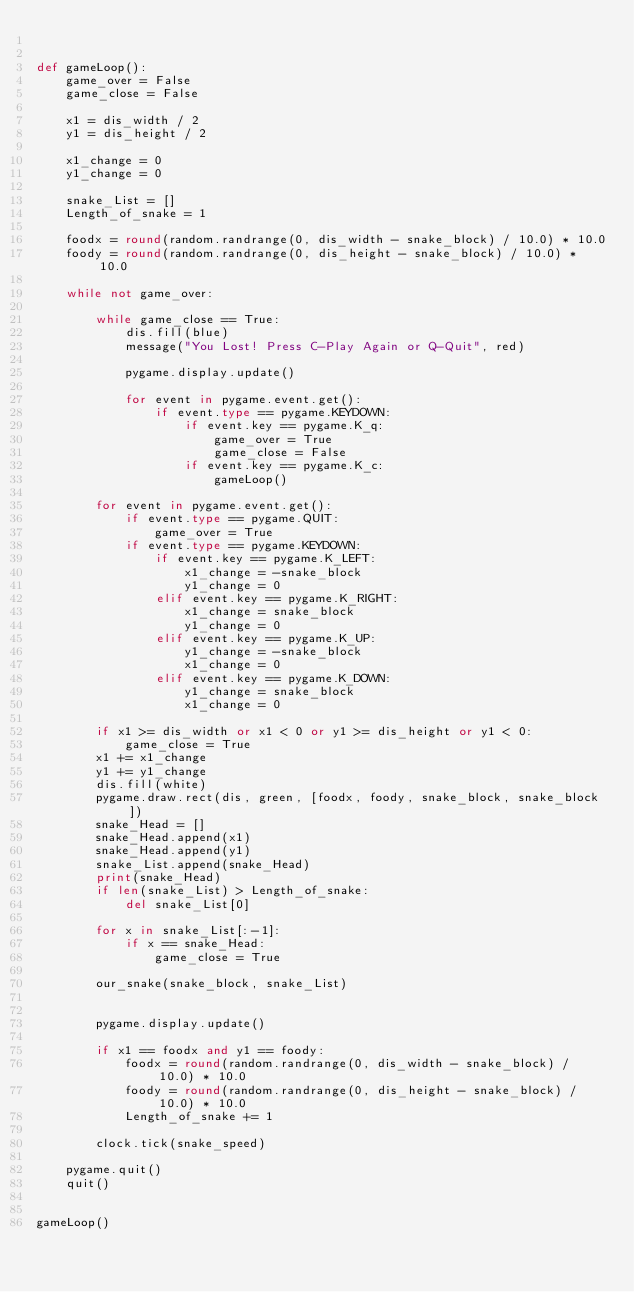<code> <loc_0><loc_0><loc_500><loc_500><_Python_> 
 
def gameLoop():
    game_over = False
    game_close = False
 
    x1 = dis_width / 2
    y1 = dis_height / 2
 
    x1_change = 0
    y1_change = 0
 
    snake_List = []
    Length_of_snake = 1
 
    foodx = round(random.randrange(0, dis_width - snake_block) / 10.0) * 10.0
    foody = round(random.randrange(0, dis_height - snake_block) / 10.0) * 10.0
 
    while not game_over:
 
        while game_close == True:
            dis.fill(blue)
            message("You Lost! Press C-Play Again or Q-Quit", red)
 
            pygame.display.update()
 
            for event in pygame.event.get():
                if event.type == pygame.KEYDOWN:
                    if event.key == pygame.K_q:
                        game_over = True
                        game_close = False
                    if event.key == pygame.K_c:
                        gameLoop()
 
        for event in pygame.event.get():
            if event.type == pygame.QUIT:
                game_over = True
            if event.type == pygame.KEYDOWN:
                if event.key == pygame.K_LEFT:
                    x1_change = -snake_block
                    y1_change = 0
                elif event.key == pygame.K_RIGHT:
                    x1_change = snake_block
                    y1_change = 0
                elif event.key == pygame.K_UP:
                    y1_change = -snake_block
                    x1_change = 0
                elif event.key == pygame.K_DOWN:
                    y1_change = snake_block
                    x1_change = 0
 
        if x1 >= dis_width or x1 < 0 or y1 >= dis_height or y1 < 0:
            game_close = True
        x1 += x1_change
        y1 += y1_change
        dis.fill(white)
        pygame.draw.rect(dis, green, [foodx, foody, snake_block, snake_block])
        snake_Head = []
        snake_Head.append(x1)
        snake_Head.append(y1)
        snake_List.append(snake_Head)
        print(snake_Head)
        if len(snake_List) > Length_of_snake:
            del snake_List[0]
 
        for x in snake_List[:-1]:
            if x == snake_Head:
                game_close = True
 
        our_snake(snake_block, snake_List)
 
 
        pygame.display.update()
 
        if x1 == foodx and y1 == foody:
            foodx = round(random.randrange(0, dis_width - snake_block) / 10.0) * 10.0
            foody = round(random.randrange(0, dis_height - snake_block) / 10.0) * 10.0
            Length_of_snake += 1
 
        clock.tick(snake_speed)
 
    pygame.quit()
    quit()
 
 
gameLoop()</code> 